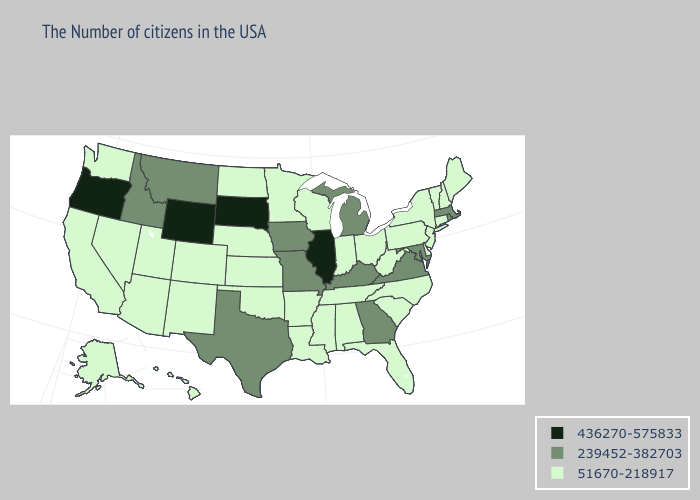What is the value of Wyoming?
Keep it brief. 436270-575833. What is the value of Louisiana?
Write a very short answer. 51670-218917. Does Rhode Island have the lowest value in the Northeast?
Quick response, please. No. Among the states that border California , does Oregon have the highest value?
Keep it brief. Yes. What is the value of Arizona?
Short answer required. 51670-218917. Name the states that have a value in the range 436270-575833?
Be succinct. Illinois, South Dakota, Wyoming, Oregon. Does Georgia have the lowest value in the USA?
Short answer required. No. Does the map have missing data?
Keep it brief. No. Among the states that border New York , does Massachusetts have the highest value?
Write a very short answer. Yes. Does Maryland have the lowest value in the USA?
Keep it brief. No. Which states have the lowest value in the Northeast?
Short answer required. Maine, New Hampshire, Vermont, Connecticut, New York, New Jersey, Pennsylvania. Which states have the lowest value in the USA?
Keep it brief. Maine, New Hampshire, Vermont, Connecticut, New York, New Jersey, Delaware, Pennsylvania, North Carolina, South Carolina, West Virginia, Ohio, Florida, Indiana, Alabama, Tennessee, Wisconsin, Mississippi, Louisiana, Arkansas, Minnesota, Kansas, Nebraska, Oklahoma, North Dakota, Colorado, New Mexico, Utah, Arizona, Nevada, California, Washington, Alaska, Hawaii. What is the value of Vermont?
Keep it brief. 51670-218917. Name the states that have a value in the range 239452-382703?
Give a very brief answer. Massachusetts, Rhode Island, Maryland, Virginia, Georgia, Michigan, Kentucky, Missouri, Iowa, Texas, Montana, Idaho. 